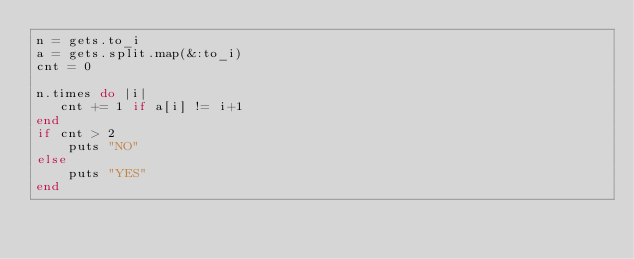Convert code to text. <code><loc_0><loc_0><loc_500><loc_500><_Ruby_>n = gets.to_i
a = gets.split.map(&:to_i)
cnt = 0

n.times do |i|
   cnt += 1 if a[i] != i+1
end
if cnt > 2
    puts "NO"
else
    puts "YES"
end</code> 